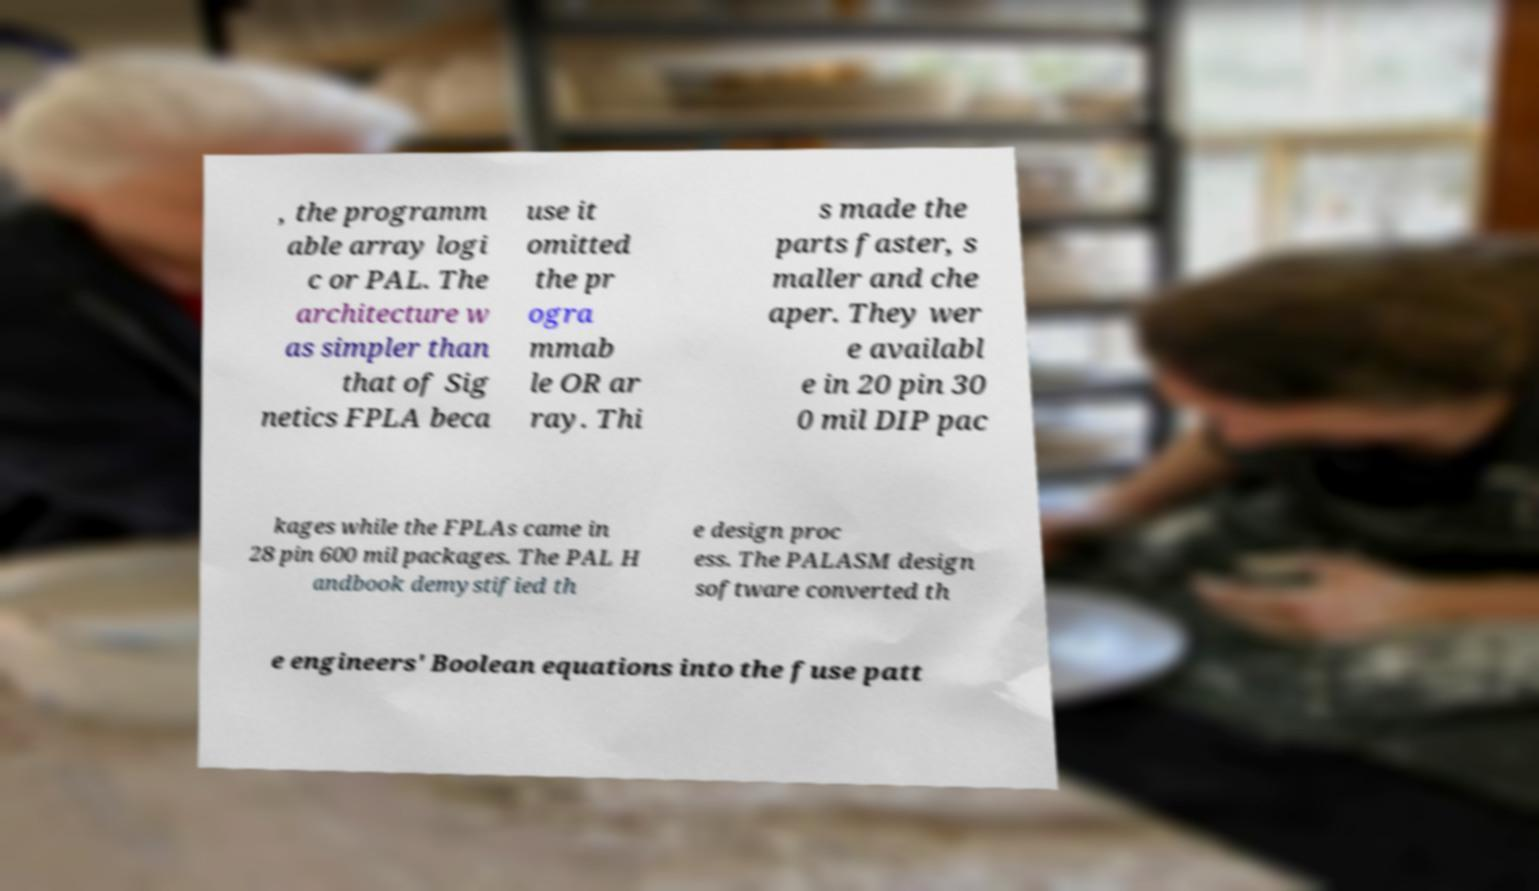Could you extract and type out the text from this image? , the programm able array logi c or PAL. The architecture w as simpler than that of Sig netics FPLA beca use it omitted the pr ogra mmab le OR ar ray. Thi s made the parts faster, s maller and che aper. They wer e availabl e in 20 pin 30 0 mil DIP pac kages while the FPLAs came in 28 pin 600 mil packages. The PAL H andbook demystified th e design proc ess. The PALASM design software converted th e engineers' Boolean equations into the fuse patt 